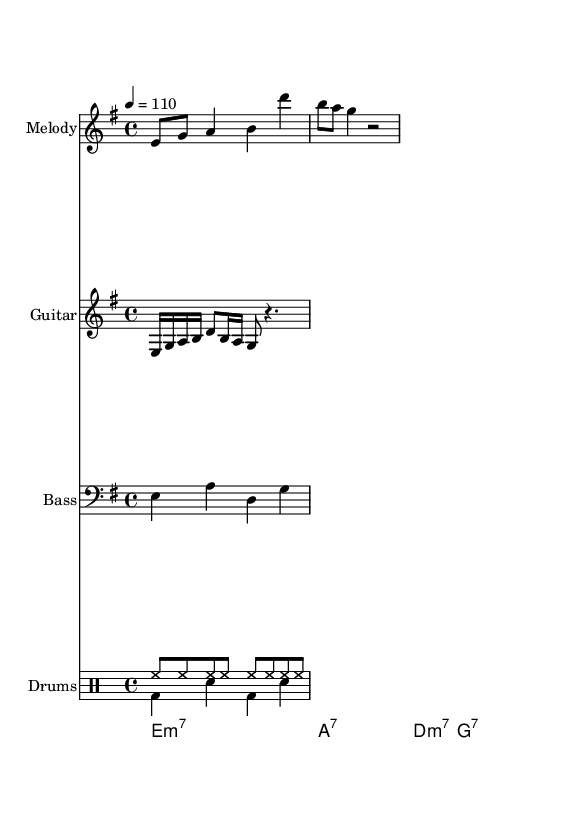What is the key signature of this music? The key signature is identified by the notes present at the beginning of the staff. Here, the music is in E minor, which has one sharp.
Answer: E minor What is the time signature of this piece? The time signature can be found next to the key signature at the beginning of the score. It is set to 4/4, indicating four beats per measure.
Answer: 4/4 What is the tempo marking? The tempo marking specifies how fast the piece is played. Here, it indicates a tempo of 110 beats per minute.
Answer: 110 How many instruments are featured in this score? By counting the different staves at the beginning, we see five distinct parts: Melody, Guitar, Bass, and Drums (two voices).
Answer: Five What type of chord is played on the first measure? The chord names given at the bottom indicate the harmonic structure of the music. The first chord is E minor 7.
Answer: E minor 7 Which rhythm pattern is used for the drums? The drum pattern is presented in two voices, with a typical funk rhythm that alternates between hi-hat and bass drum. It combines a steady hi-hat pattern with syncopated accents from the bass drum.
Answer: Funk rhythm What is the primary genre indicated by the structure of this music? The arrangement, including guitars, bass, extended grooves, and rhythmic drum patterns, points strongly towards funk-rock as a genre.
Answer: Funk-rock 